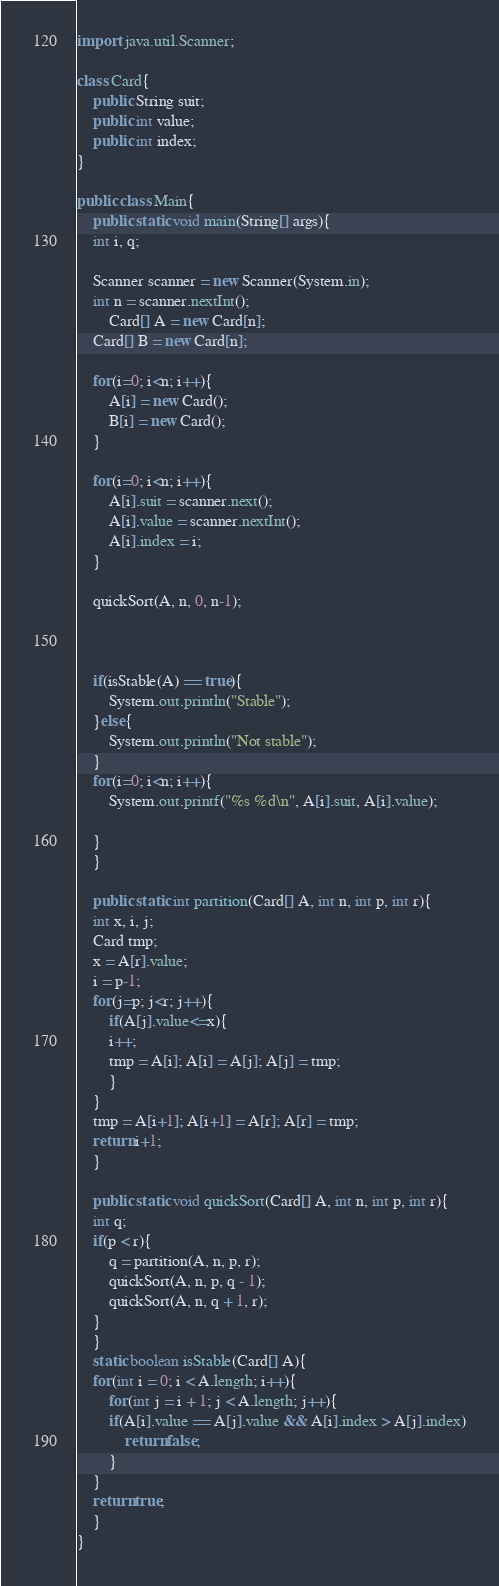Convert code to text. <code><loc_0><loc_0><loc_500><loc_500><_Java_>import java.util.Scanner;

class Card{
    public String suit;
    public int value;
    public int index;
}

public class Main{
    public static void main(String[] args){
	int i, q;
	
	Scanner scanner = new Scanner(System.in);
	int n = scanner.nextInt();
    	Card[] A = new Card[n];
	Card[] B = new Card[n];

	for(i=0; i<n; i++){
	    A[i] = new Card();
	    B[i] = new Card();
	}

	for(i=0; i<n; i++){
	    A[i].suit = scanner.next();
	    A[i].value = scanner.nextInt();
	    A[i].index = i; 
	}

	quickSort(A, n, 0, n-1);

	

	if(isStable(A) == true){
	    System.out.println("Stable");
	}else{
	    System.out.println("Not stable");
	}
	for(i=0; i<n; i++){
	    System.out.printf("%s %d\n", A[i].suit, A[i].value);
	    
	}
    }
    
    public static int partition(Card[] A, int n, int p, int r){
	int x, i, j;
	Card tmp;
	x = A[r].value;
	i = p-1;
	for(j=p; j<r; j++){
	    if(A[j].value<=x){
		i++;
		tmp = A[i]; A[i] = A[j]; A[j] = tmp;
	    }
	}
	tmp = A[i+1]; A[i+1] = A[r]; A[r] = tmp;
	return i+1;
    }

    public static void quickSort(Card[] A, int n, int p, int r){
	int q;
	if(p < r){
	    q = partition(A, n, p, r);
	    quickSort(A, n, p, q - 1);
	    quickSort(A, n, q + 1, r); 
	}
    }
    static boolean isStable(Card[] A){
	for(int i = 0; i < A.length; i++){
	    for(int j = i + 1; j < A.length; j++){
		if(A[i].value == A[j].value && A[i].index > A[j].index)
		    return false;
	    }
	}
    return true;
    }	    
}
</code> 